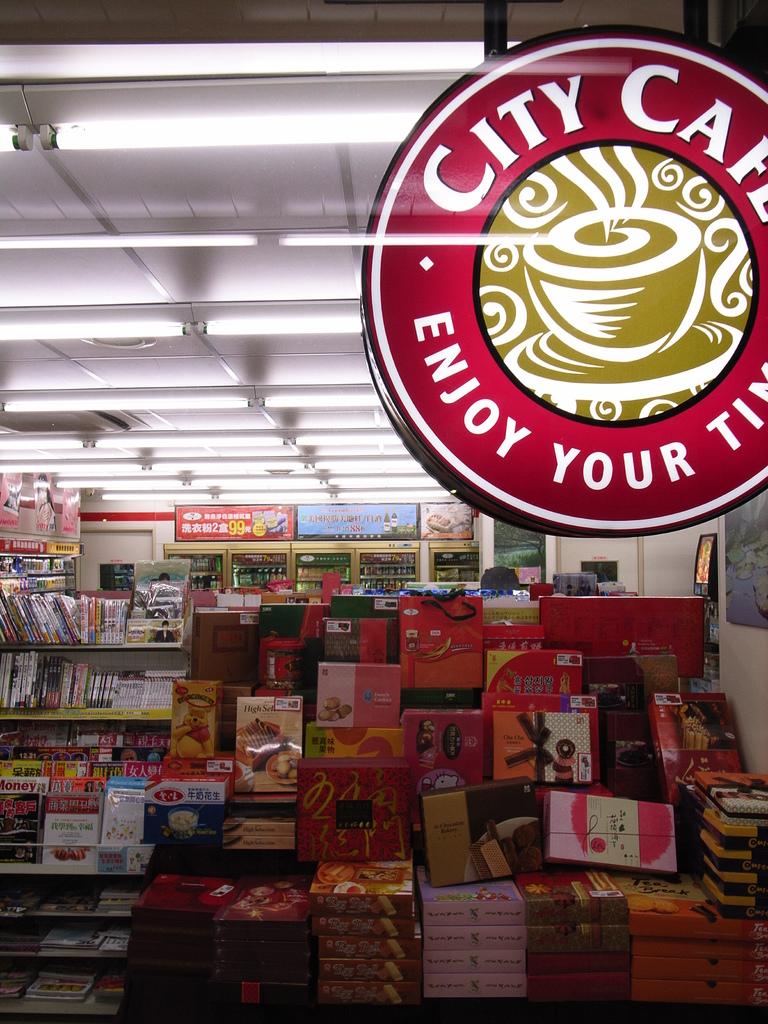What does city cafe want you to do?
Your answer should be very brief. Enjoy your time. What is the name of the cafe?
Your response must be concise. City cafe. 